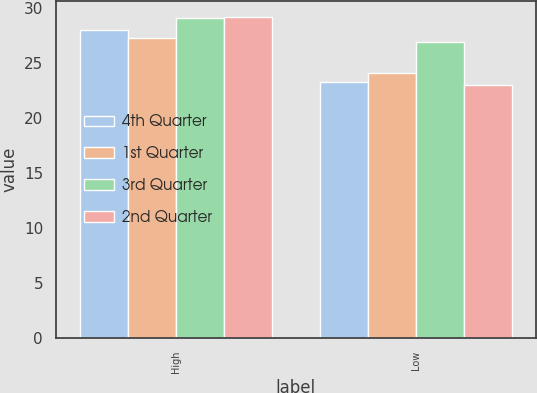Convert chart. <chart><loc_0><loc_0><loc_500><loc_500><stacked_bar_chart><ecel><fcel>High<fcel>Low<nl><fcel>4th Quarter<fcel>28.02<fcel>23.32<nl><fcel>1st Quarter<fcel>27.29<fcel>24.13<nl><fcel>3rd Quarter<fcel>29.09<fcel>26.9<nl><fcel>2nd Quarter<fcel>29.17<fcel>23.01<nl></chart> 